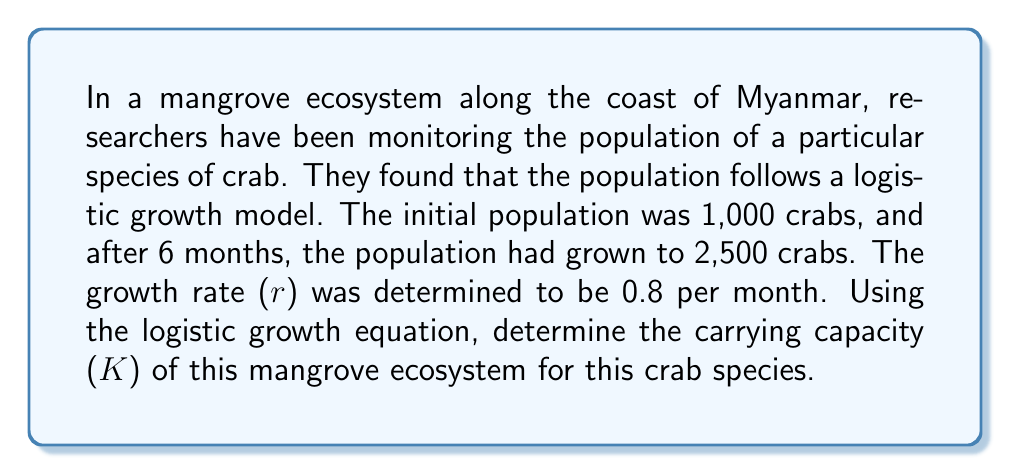Solve this math problem. To solve this problem, we'll use the logistic growth equation and the given information. Let's break it down step-by-step:

1. The logistic growth equation is:

   $$N(t) = \frac{K}{1 + (\frac{K}{N_0} - 1)e^{-rt}}$$

   Where:
   $N(t)$ is the population at time $t$
   $K$ is the carrying capacity
   $N_0$ is the initial population
   $r$ is the growth rate
   $t$ is the time

2. We know:
   $N_0 = 1,000$ (initial population)
   $N(6) = 2,500$ (population after 6 months)
   $r = 0.8$ per month
   $t = 6$ months

3. Let's substitute these values into the equation:

   $$2,500 = \frac{K}{1 + (\frac{K}{1,000} - 1)e^{-0.8 \cdot 6}}$$

4. Simplify the exponent:
   
   $$2,500 = \frac{K}{1 + (\frac{K}{1,000} - 1)e^{-4.8}}$$

5. Let $a = e^{-4.8}$ for simplicity:

   $$2,500 = \frac{K}{1 + (\frac{K}{1,000} - 1)a}$$

6. Multiply both sides by the denominator:

   $$2,500 + 2,500(\frac{K}{1,000} - 1)a = K$$

7. Expand:

   $$2,500 + 2.5Ka - 2,500a = K$$

8. Rearrange to standard form:

   $$2.5Ka - K - 2,500a + 2,500 = 0$$

9. Factor out K:

   $$K(2.5a - 1) - 2,500a + 2,500 = 0$$

10. Solve for K:

    $$K = \frac{2,500a - 2,500}{2.5a - 1}$$

11. Calculate $a = e^{-4.8} \approx 0.00821$

12. Substitute this value and solve:

    $$K = \frac{2,500(0.00821) - 2,500}{2.5(0.00821) - 1} \approx 3,378.38$$

The carrying capacity is approximately 3,378 crabs.
Answer: The carrying capacity (K) of the mangrove ecosystem for this crab species is approximately 3,378 crabs. 